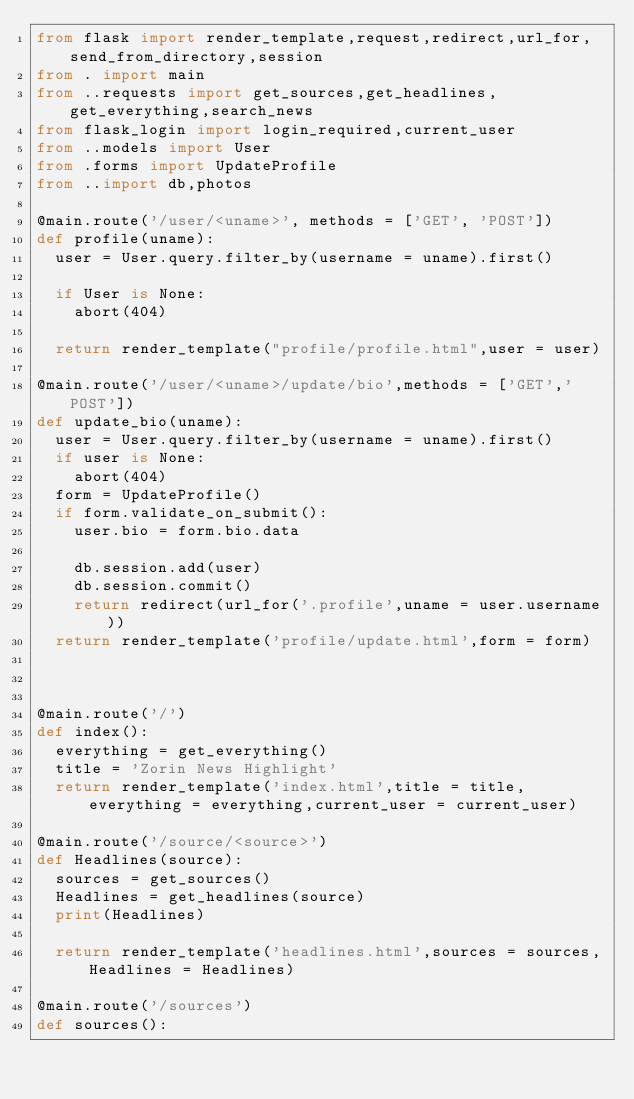<code> <loc_0><loc_0><loc_500><loc_500><_Python_>from flask import render_template,request,redirect,url_for,send_from_directory,session
from . import main
from ..requests import get_sources,get_headlines,get_everything,search_news
from flask_login import login_required,current_user
from ..models import User
from .forms import UpdateProfile
from ..import db,photos

@main.route('/user/<uname>', methods = ['GET', 'POST'])
def profile(uname):
	user = User.query.filter_by(username = uname).first()

	if User is None:
		abort(404)

	return render_template("profile/profile.html",user = user)

@main.route('/user/<uname>/update/bio',methods = ['GET','POST'])
def update_bio(uname):
	user = User.query.filter_by(username = uname).first()
	if user is None:
		abort(404)
	form = UpdateProfile()
	if form.validate_on_submit():
		user.bio = form.bio.data

		db.session.add(user)
		db.session.commit()
		return redirect(url_for('.profile',uname = user.username))
	return render_template('profile/update.html',form = form)



@main.route('/')
def index():
	everything = get_everything()
	title = 'Zorin News Highlight'
	return render_template('index.html',title = title,everything = everything,current_user = current_user)

@main.route('/source/<source>')
def Headlines(source):
	sources = get_sources()
	Headlines = get_headlines(source)
	print(Headlines)

	return render_template('headlines.html',sources = sources,Headlines = Headlines)

@main.route('/sources')
def sources():</code> 